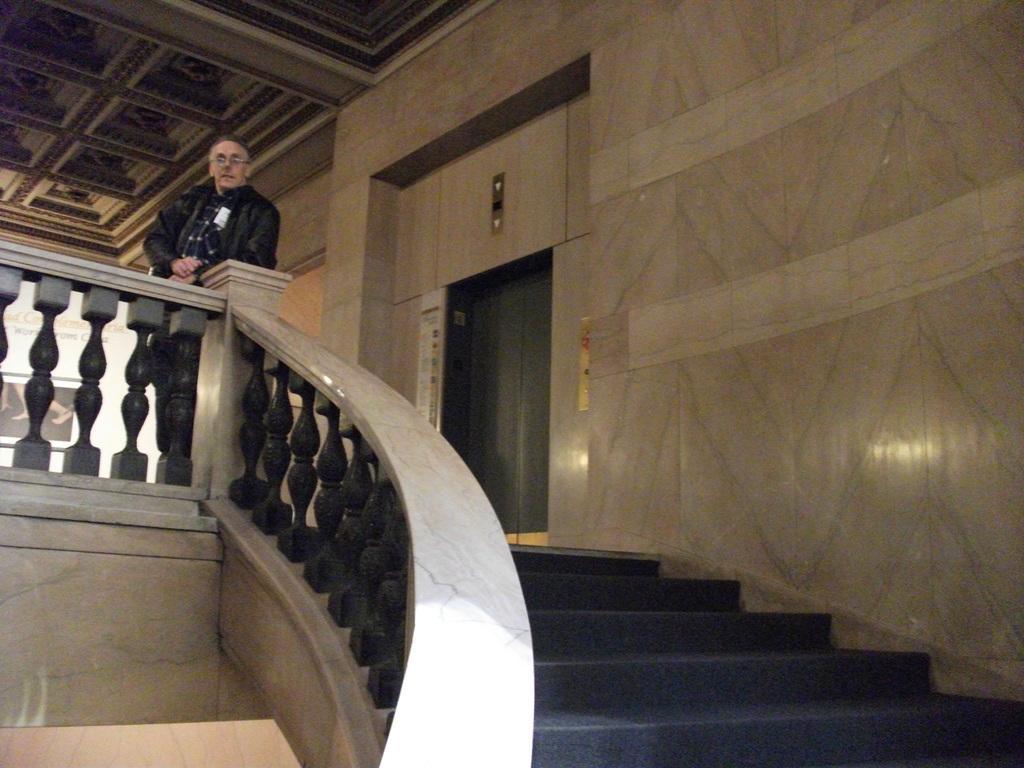How would you summarize this image in a sentence or two? The picture is taken in a building. In the foreground it is staircase. In the center of the picture there is a person and lift. At the top it is ceiling. 